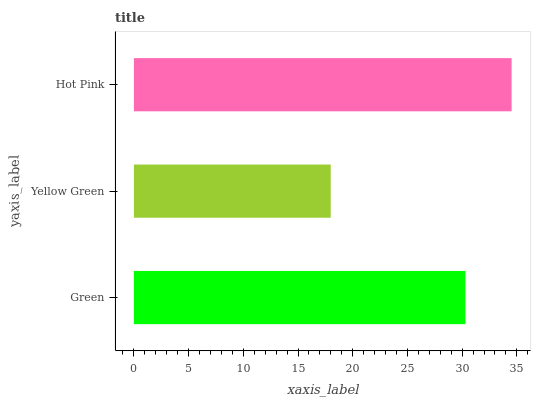Is Yellow Green the minimum?
Answer yes or no. Yes. Is Hot Pink the maximum?
Answer yes or no. Yes. Is Hot Pink the minimum?
Answer yes or no. No. Is Yellow Green the maximum?
Answer yes or no. No. Is Hot Pink greater than Yellow Green?
Answer yes or no. Yes. Is Yellow Green less than Hot Pink?
Answer yes or no. Yes. Is Yellow Green greater than Hot Pink?
Answer yes or no. No. Is Hot Pink less than Yellow Green?
Answer yes or no. No. Is Green the high median?
Answer yes or no. Yes. Is Green the low median?
Answer yes or no. Yes. Is Yellow Green the high median?
Answer yes or no. No. Is Hot Pink the low median?
Answer yes or no. No. 